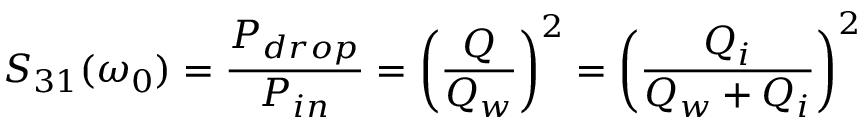<formula> <loc_0><loc_0><loc_500><loc_500>S _ { 3 1 } ( \omega _ { 0 } ) = \frac { P _ { d r o p } } { P _ { i n } } = \left ( \frac { Q } { Q _ { w } } \right ) ^ { 2 } = \left ( \frac { Q _ { i } } { Q _ { w } + Q _ { i } } \right ) ^ { 2 }</formula> 